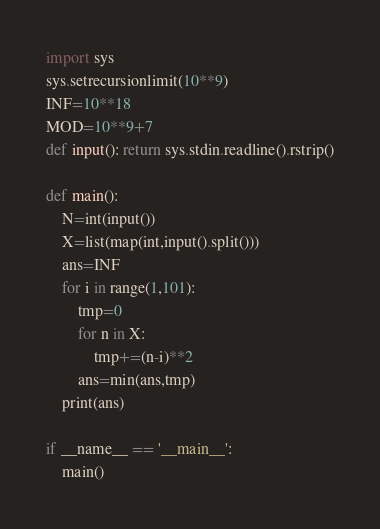<code> <loc_0><loc_0><loc_500><loc_500><_Python_>import sys
sys.setrecursionlimit(10**9)
INF=10**18
MOD=10**9+7
def input(): return sys.stdin.readline().rstrip()

def main():
    N=int(input())
    X=list(map(int,input().split()))
    ans=INF
    for i in range(1,101):
        tmp=0
        for n in X:
            tmp+=(n-i)**2
        ans=min(ans,tmp)
    print(ans)

if __name__ == '__main__':
    main()
</code> 